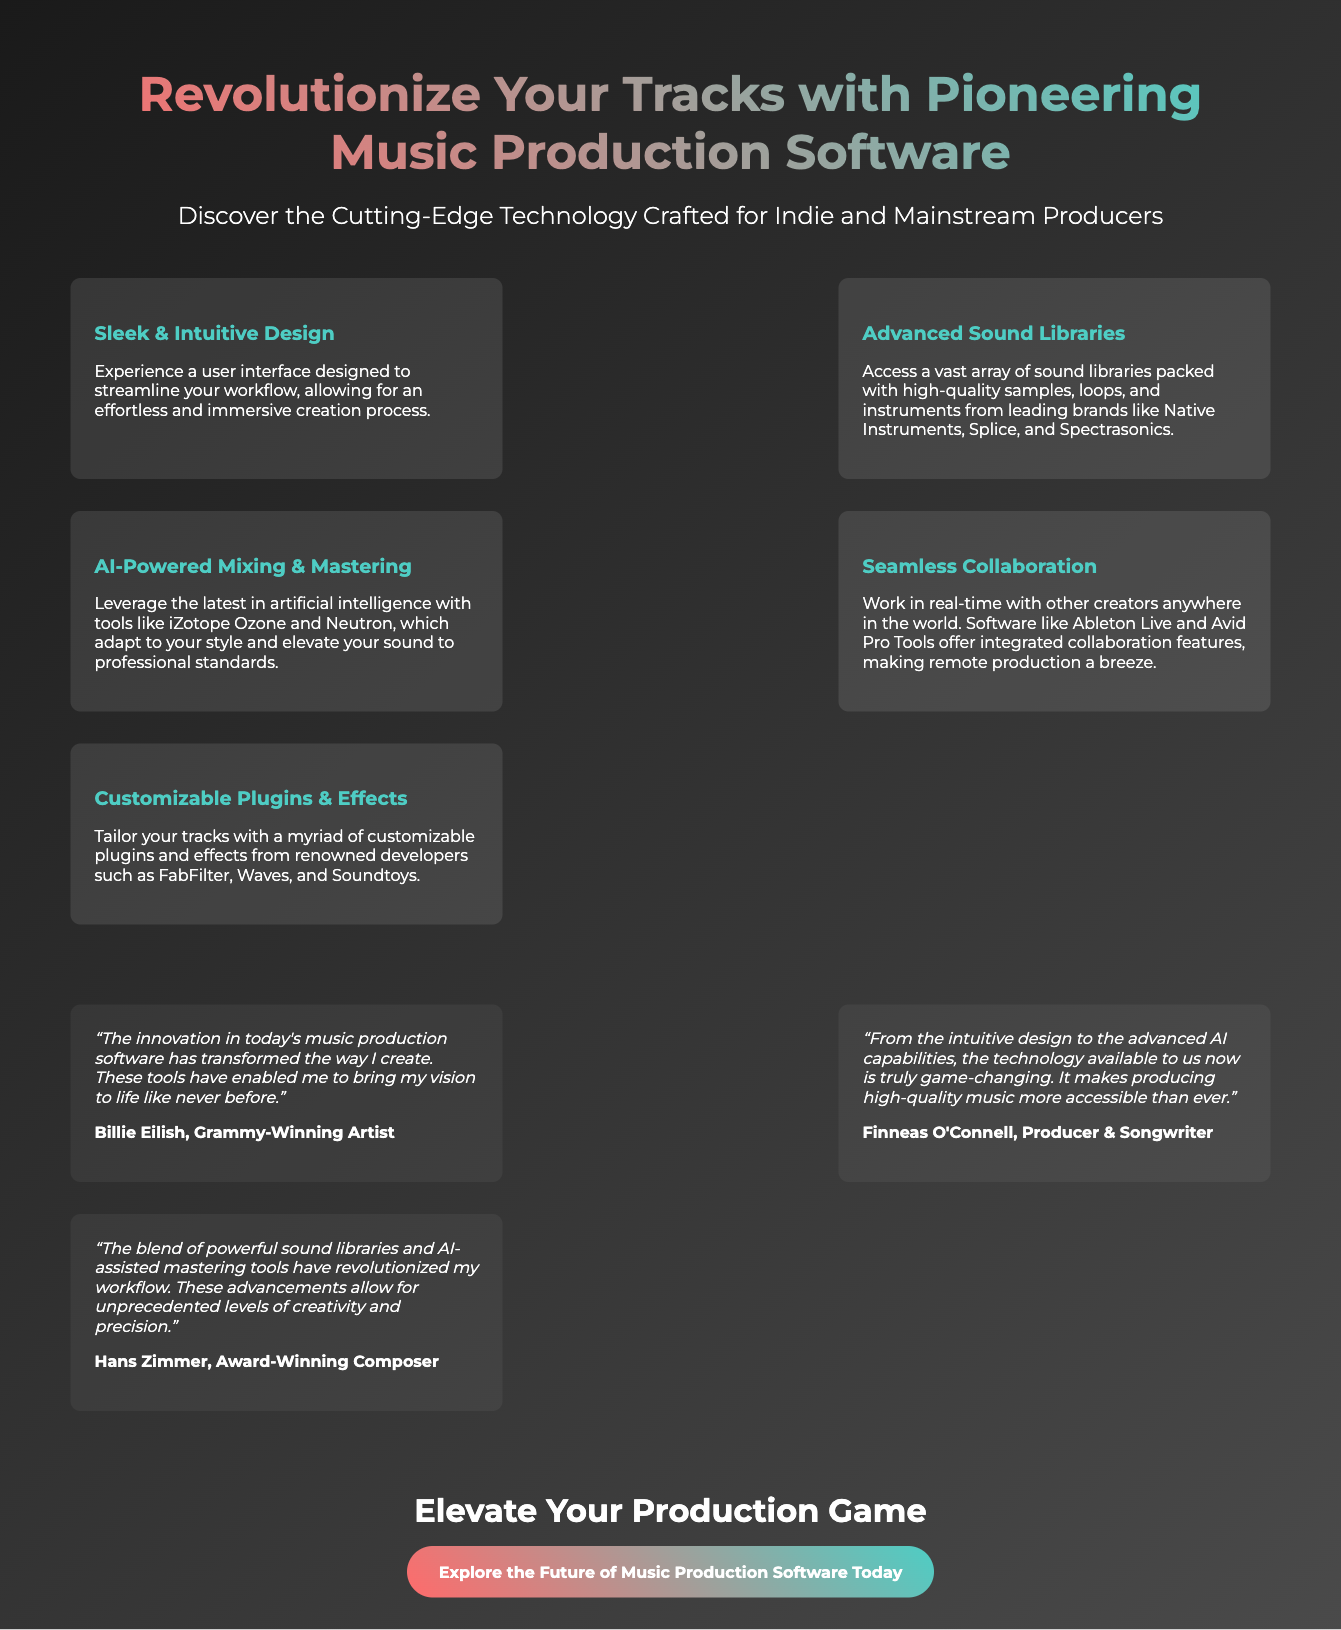What is the title of the advertisement? The title of the advertisement is prominently displayed at the top of the document.
Answer: Revolutionize Your Tracks with Pioneering Music Production Software Who is the first testimonial from? The first testimonial includes the name of the artist, which represents a key endorsement.
Answer: Billie Eilish What is one of the advanced features highlighted in the advertisement? The advertisement lists various features, one of which is mentioned in the features section.
Answer: AI-Powered Mixing & Mastering Which brands are mentioned as part of the sound libraries? Specific brands are referenced in the features section regarding the sound libraries available.
Answer: Native Instruments, Splice, and Spectrasonics What is the main purpose of the call to action? The call to action encourages the audience to engage further with the product promoted.
Answer: Elevate Your Production Game Which section of the advertisement focuses on user feedback? The section provides direct quotes from professionals in the industry regarding their experiences.
Answer: Testimonials What color scheme is used in the header text? The header text has a specific gradient color scheme designed to draw attention.
Answer: Gradient (from #ff6b6b to #4ecdc4) How many features are listed in the advertisement? The number of features can be counted in the features section of the document.
Answer: Five 